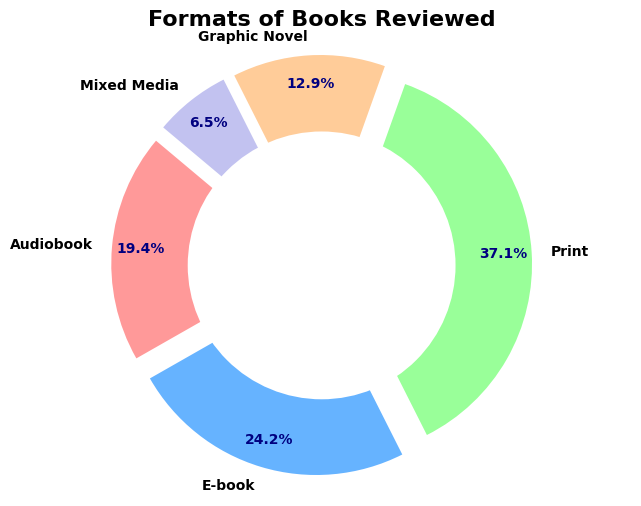What is the most reviewed book format? From looking at the pie chart, the largest slice represents the Print format.
Answer: Print Which book format has the smallest number of reviews? The pie chart shows the smallest slice for the Mixed Media format.
Answer: Mixed Media What percentage of books reviewed are in Graphic Novel format? The pie chart labels show that the Graphic Novel slice is marked as 13.0%.
Answer: 13.0% How does the count of E-book reviews compare to Audiobook reviews? By observing the sizes of the slices, E-book is larger than Audiobook. The E-book has 150 reviews, while Audiobook has 120 reviews.
Answer: E-book is larger What is the combined percentage of reviews for the Audiobook and E-book formats? The Audiobook slice is labeled with 21.1%, and E-book with 26.4%. Adding these two percentages together gives 21.1% + 26.4% = 47.5%.
Answer: 47.5% How many more reviews does Print format have compared to Graphic Novel format? Print has 230 reviews while Graphic Novel has 80 reviews. The difference is 230 - 80 = 150.
Answer: 150 Between Mixed Media and Audiobook formats, which one has a higher count, and by how much? Audiobook has 120 reviews, while Mixed Media has 40 reviews. The difference is 120 - 40 = 80, so Audiobook is higher by 80 reviews.
Answer: Audiobook, by 80 Which format represents approximately one-fourth of the total reviews? The pie chart shows that the E-book slice is close to a quarter of the pie with 26.4%.
Answer: E-book How many formats have a count above 100 reviews? Print has 230, E-book has 150, and Audiobook has 120. So, there are three formats with counts above 100 reviews.
Answer: Three If we combine the reviews for Graphic Novels and Mixed Media formats, what fraction of the total reviews do they represent? Graphic Novels have 80 reviews, and Mixed Media has 40 reviews, adding up to 80 + 40 = 120. The total number of reviews is 620 (120 + 150 + 230 + 80 + 40). The fraction is 120 / 620, which simplifies to approximately 19.4%.
Answer: 19.4% 